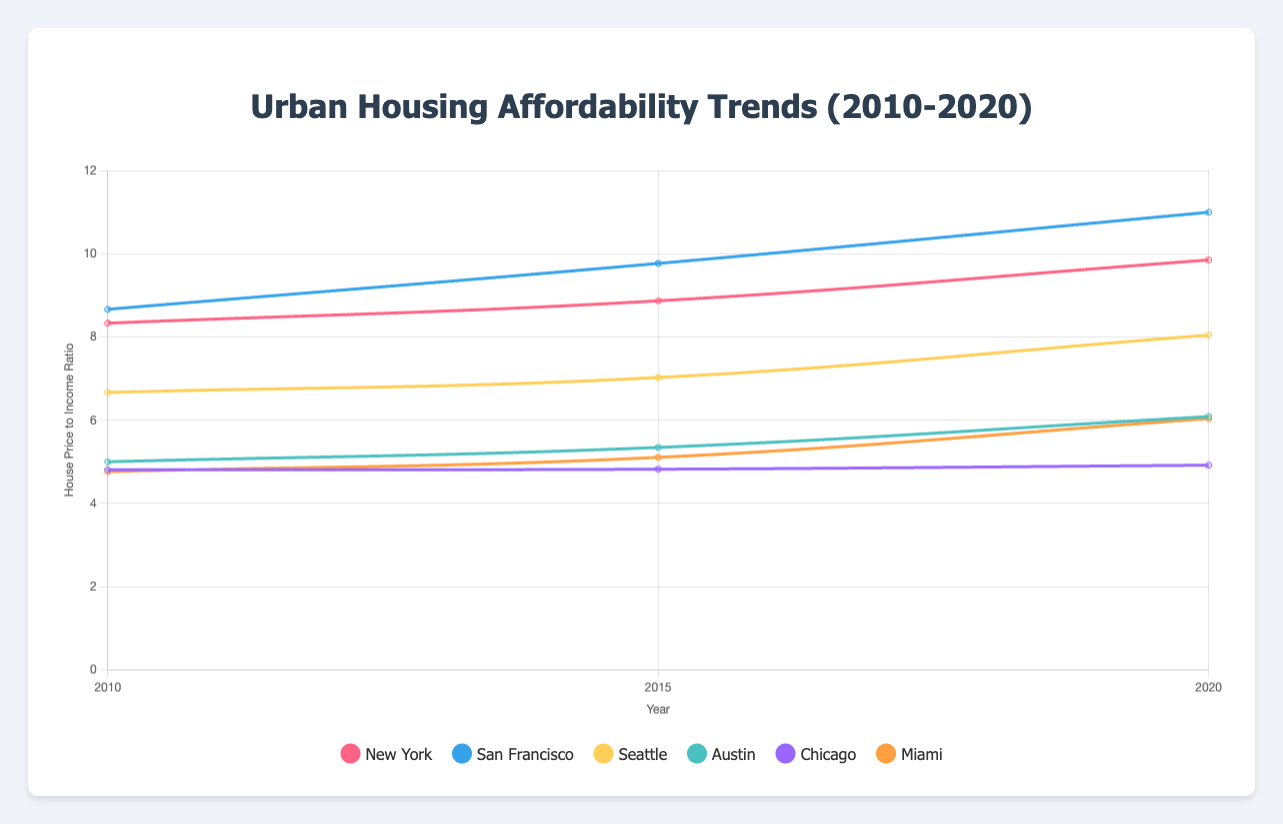What is the trend in the house price to income ratio for New York from 2010 to 2020? Looking at the line representing New York City in the chart, the ratios for 2010, 2015, and 2020 are approximately 8.33, 8.87, and 9.85 respectively. This shows an increasing trend in the house price to income ratio over the period.
Answer: Increasing Which city had the highest house price to income ratio in 2020? By examining the data points for 2020, San Francisco had the highest house price to income ratio, with a value around 11.
Answer: San Francisco How does the house price to income ratio in 2020 compare between Seattle and Austin? The chart shows that in 2020, Seattle's ratio is approximately 8.05, while Austin's ratio is around 6.09. Therefore, Seattle's ratio is higher than Austin's.
Answer: Seattle's ratio is higher What is the average house price to income ratio for Chicago across the years 2010, 2015, and 2020? The ratios for Chicago in 2010, 2015, and 2020 are approximately 4.81, 4.82, and 4.92 respectively. The average is calculated as (4.81+4.82+4.92)/3, which equals 4.85.
Answer: 4.85 Which city experienced the greatest increase in the house price to income ratio from 2010 to 2020? By comparing the start and end points of each city's line, San Francisco had an increase from roughly 8.67 to 11, an increase of 2.33. This is the greatest increase among the cities.
Answer: San Francisco In 2015, which city had a lower house price to income ratio: Miami or Chicago? In 2015, Miami's ratio is around 5.11, while Chicago’s ratio is approximately 4.82. Thus, Chicago had the lower ratio.
Answer: Chicago What is the percentage change in the house price to income ratio for Miami from 2010 to 2020? Miami's ratio in 2010 and 2020 can be derived as 4.76 and 6.04 respectively. The percentage change is calculated as ((6.04 - 4.76) / 4.76) * 100, which is approximately 26.89%.
Answer: 26.89% Among New York, San Francisco, and Seattle, which city had the most stable house price to income ratio between 2010 and 2020? Observing the fluctuations for each city, New York had the smallest increase in ratios from 2010 to 2020 (8.33 to 9.85), suggesting it had the most stable ratio among the three.
Answer: New York How does the house price to income ratio for Austin in 2020 compare to its ratio in 2010? Austin's ratio in 2010 was 5.00, while in 2020 it was 6.09, indicating an increase.
Answer: Increased 